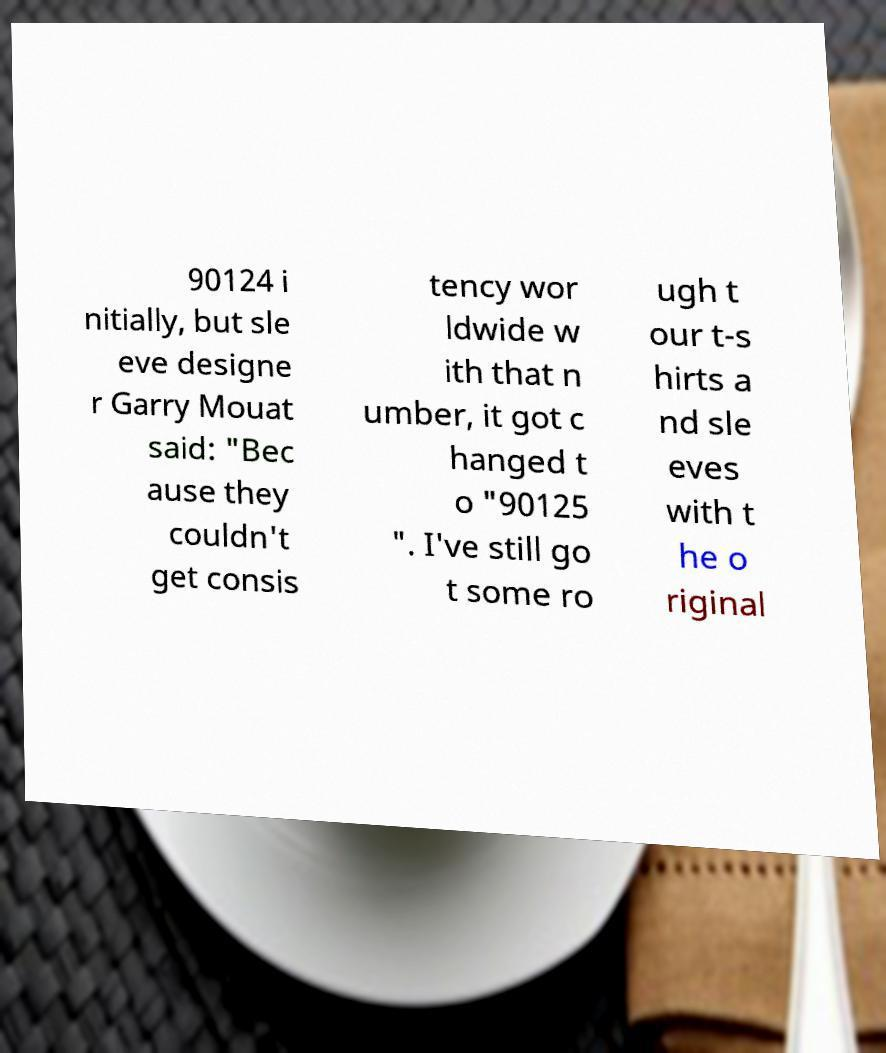Please identify and transcribe the text found in this image. 90124 i nitially, but sle eve designe r Garry Mouat said: "Bec ause they couldn't get consis tency wor ldwide w ith that n umber, it got c hanged t o "90125 ". I've still go t some ro ugh t our t-s hirts a nd sle eves with t he o riginal 